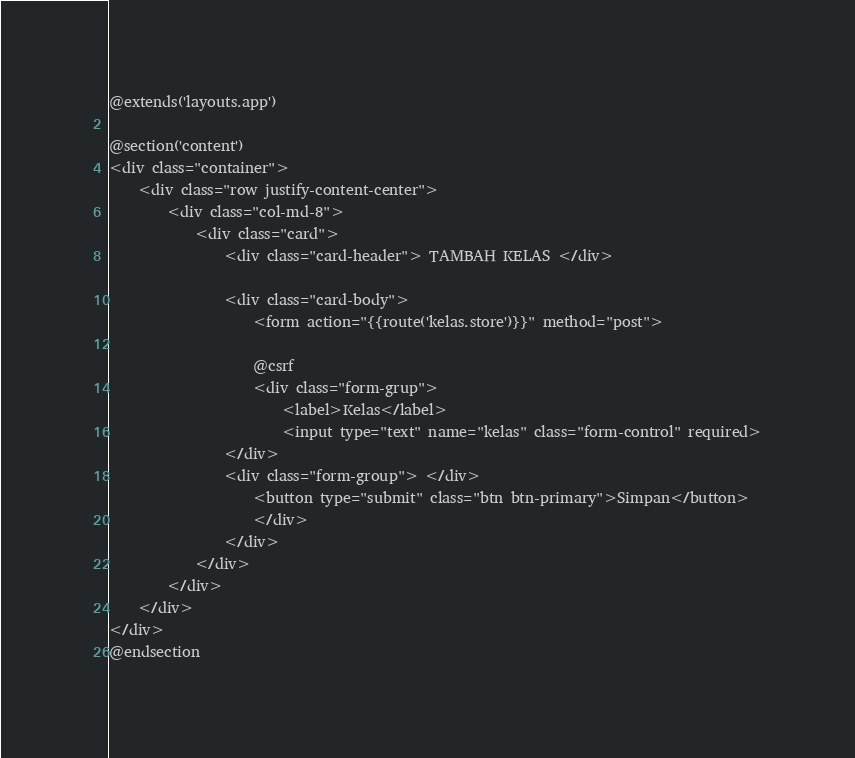<code> <loc_0><loc_0><loc_500><loc_500><_PHP_>@extends('layouts.app')

@section('content')
<div class="container">
    <div class="row justify-content-center">
        <div class="col-md-8">
            <div class="card">
                <div class="card-header"> TAMBAH KELAS </div>

                <div class="card-body">
                    <form action="{{route('kelas.store')}}" method="post">
                    
                    @csrf
                    <div class="form-grup">
                        <label>Kelas</label>
                        <input type="text" name="kelas" class="form-control" required>
                </div>
                <div class="form-group"> </div>
                    <button type="submit" class="btn btn-primary">Simpan</button>
                    </div>
                </div>
            </div>
        </div>
    </div>
</div>
@endsection
</code> 